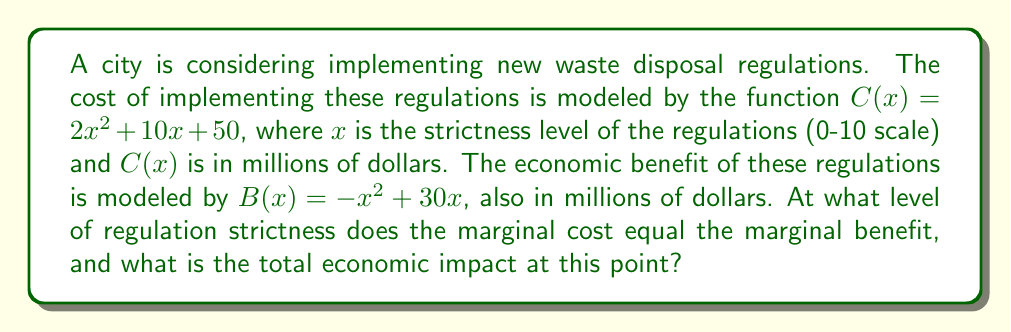What is the answer to this math problem? To solve this problem, we need to follow these steps:

1) First, we need to find the marginal cost and marginal benefit functions by taking the derivatives of $C(x)$ and $B(x)$:

   Marginal Cost: $C'(x) = 4x + 10$
   Marginal Benefit: $B'(x) = -2x + 30$

2) To find the point where marginal cost equals marginal benefit, we set these equal:

   $C'(x) = B'(x)$
   $4x + 10 = -2x + 30$
   $6x = 20$
   $x = \frac{20}{6} = \frac{10}{3} \approx 3.33$

3) This value of $x$ represents the optimal strictness level. To find the total economic impact, we need to calculate the difference between benefit and cost at this point:

   Total Impact = $B(x) - C(x)$

4) Let's calculate $B(\frac{10}{3})$ and $C(\frac{10}{3})$:

   $B(\frac{10}{3}) = -(\frac{10}{3})^2 + 30(\frac{10}{3}) = -\frac{100}{9} + 100 = \frac{800}{9} \approx 88.89$

   $C(\frac{10}{3}) = 2(\frac{10}{3})^2 + 10(\frac{10}{3}) + 50 = \frac{200}{9} + \frac{100}{3} + 50 = \frac{650}{9} \approx 72.22$

5) Therefore, the total economic impact is:

   Total Impact = $\frac{800}{9} - \frac{650}{9} = \frac{150}{9} \approx 16.67$ million dollars
Answer: The optimal strictness level is $\frac{10}{3}$ (approximately 3.33 on the 0-10 scale), and the total economic impact at this point is $\frac{150}{9}$ million dollars (approximately $16.67 million). 